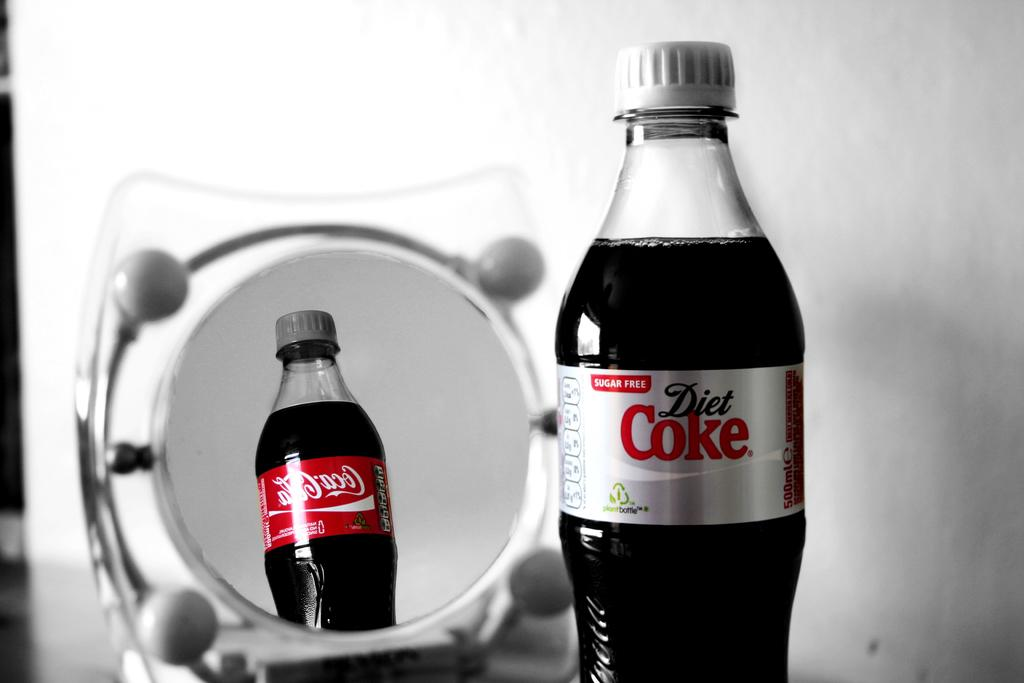What is in the image that has a label on it? There is a bottle in the image, and it has "Diet Coke" written on it. What can be seen in the background of the image? There is a mirror in the background of the image. What is reflected in the mirror? The reflection of the bottle is visible in the mirror. What thrill ride is visible in the image? There is no thrill ride present in the image; it features a bottle with "Diet Coke" written on it and a mirror in the background. 